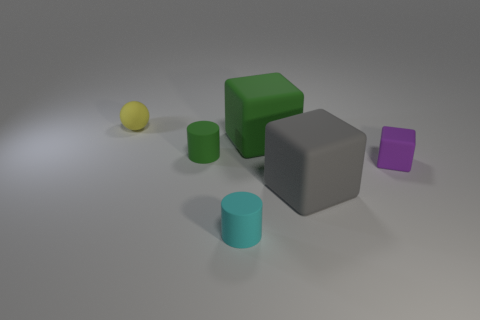Is there a cyan rubber sphere?
Make the answer very short. No. Is there a thing that is right of the tiny matte cylinder that is left of the matte cylinder to the right of the small green cylinder?
Offer a very short reply. Yes. Do the small purple object and the green matte object to the right of the tiny cyan cylinder have the same shape?
Ensure brevity in your answer.  Yes. What is the color of the cylinder that is left of the tiny matte object in front of the tiny thing that is right of the cyan matte thing?
Give a very brief answer. Green. What number of objects are either matte objects to the right of the large green cube or cubes on the left side of the tiny block?
Offer a terse response. 3. Does the tiny rubber object to the right of the cyan thing have the same shape as the big gray object?
Your answer should be very brief. Yes. Is the number of tiny cyan rubber things to the left of the tiny purple rubber thing less than the number of things?
Your response must be concise. Yes. Are there any small green things made of the same material as the purple object?
Keep it short and to the point. Yes. There is a green thing that is the same size as the purple block; what material is it?
Your response must be concise. Rubber. Is the number of small cyan rubber cylinders right of the gray object less than the number of small yellow objects that are in front of the tiny purple matte cube?
Provide a succinct answer. No. 